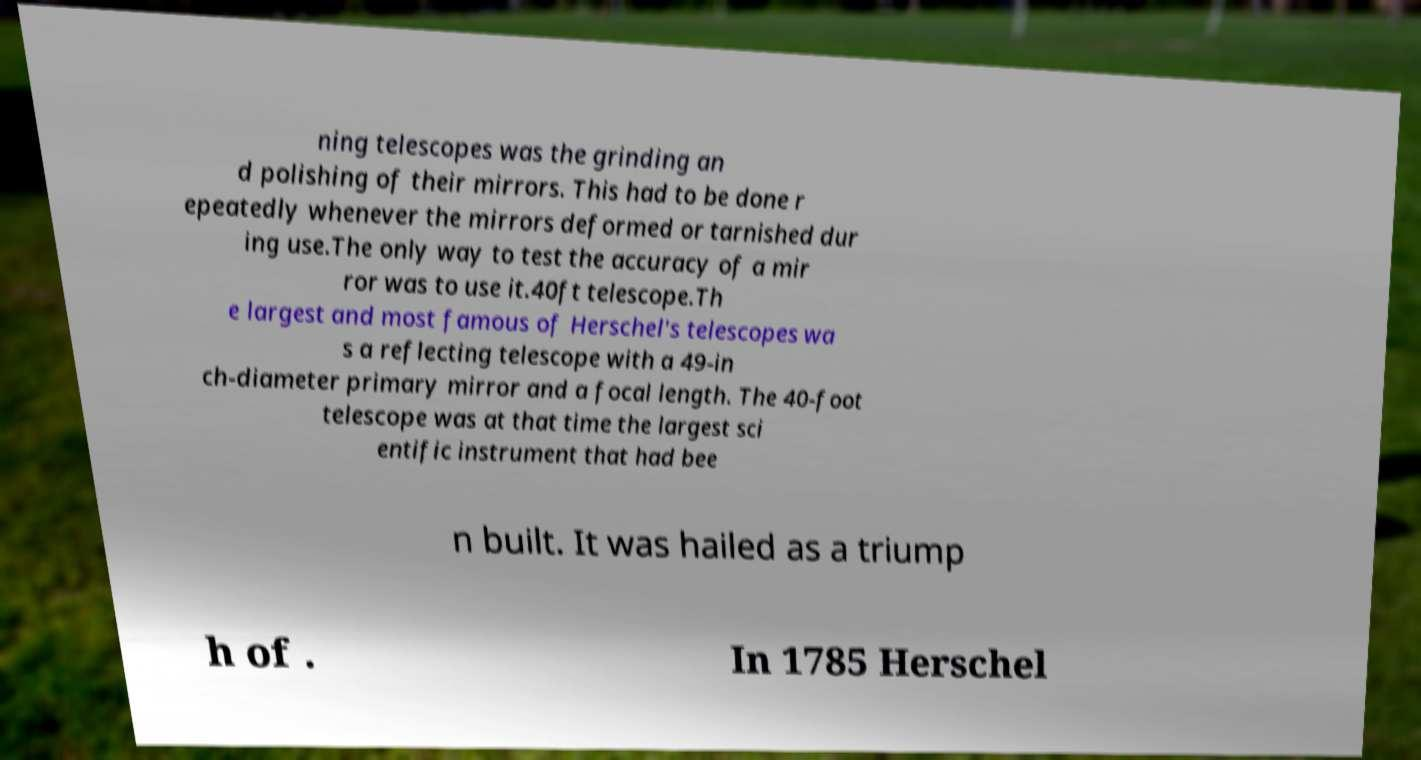What messages or text are displayed in this image? I need them in a readable, typed format. ning telescopes was the grinding an d polishing of their mirrors. This had to be done r epeatedly whenever the mirrors deformed or tarnished dur ing use.The only way to test the accuracy of a mir ror was to use it.40ft telescope.Th e largest and most famous of Herschel's telescopes wa s a reflecting telescope with a 49-in ch-diameter primary mirror and a focal length. The 40-foot telescope was at that time the largest sci entific instrument that had bee n built. It was hailed as a triump h of . In 1785 Herschel 